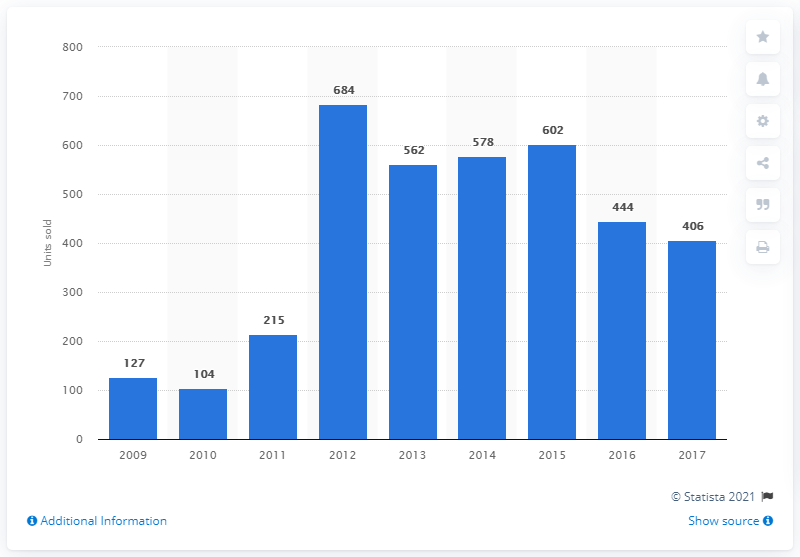Give some essential details in this illustration. In 2009, 127 Land Rover cars were sold in Norway. In 2012, a record-breaking 684 Land Rover cars were sold in Norway, making it the most successful year for the brand in that country. 